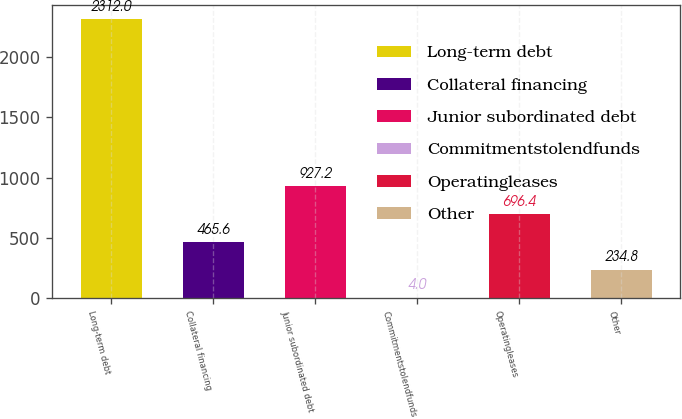Convert chart to OTSL. <chart><loc_0><loc_0><loc_500><loc_500><bar_chart><fcel>Long-term debt<fcel>Collateral financing<fcel>Junior subordinated debt<fcel>Commitmentstolendfunds<fcel>Operatingleases<fcel>Other<nl><fcel>2312<fcel>465.6<fcel>927.2<fcel>4<fcel>696.4<fcel>234.8<nl></chart> 